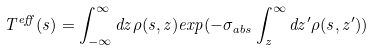Convert formula to latex. <formula><loc_0><loc_0><loc_500><loc_500>T ^ { e f f } ( { s } ) = \int _ { - \infty } ^ { \infty } d z \rho ( { s } , z ) e x p ( - \sigma _ { a b s } \int _ { z } ^ { \infty } d z ^ { \prime } \rho ( { s } , z ^ { \prime } ) )</formula> 